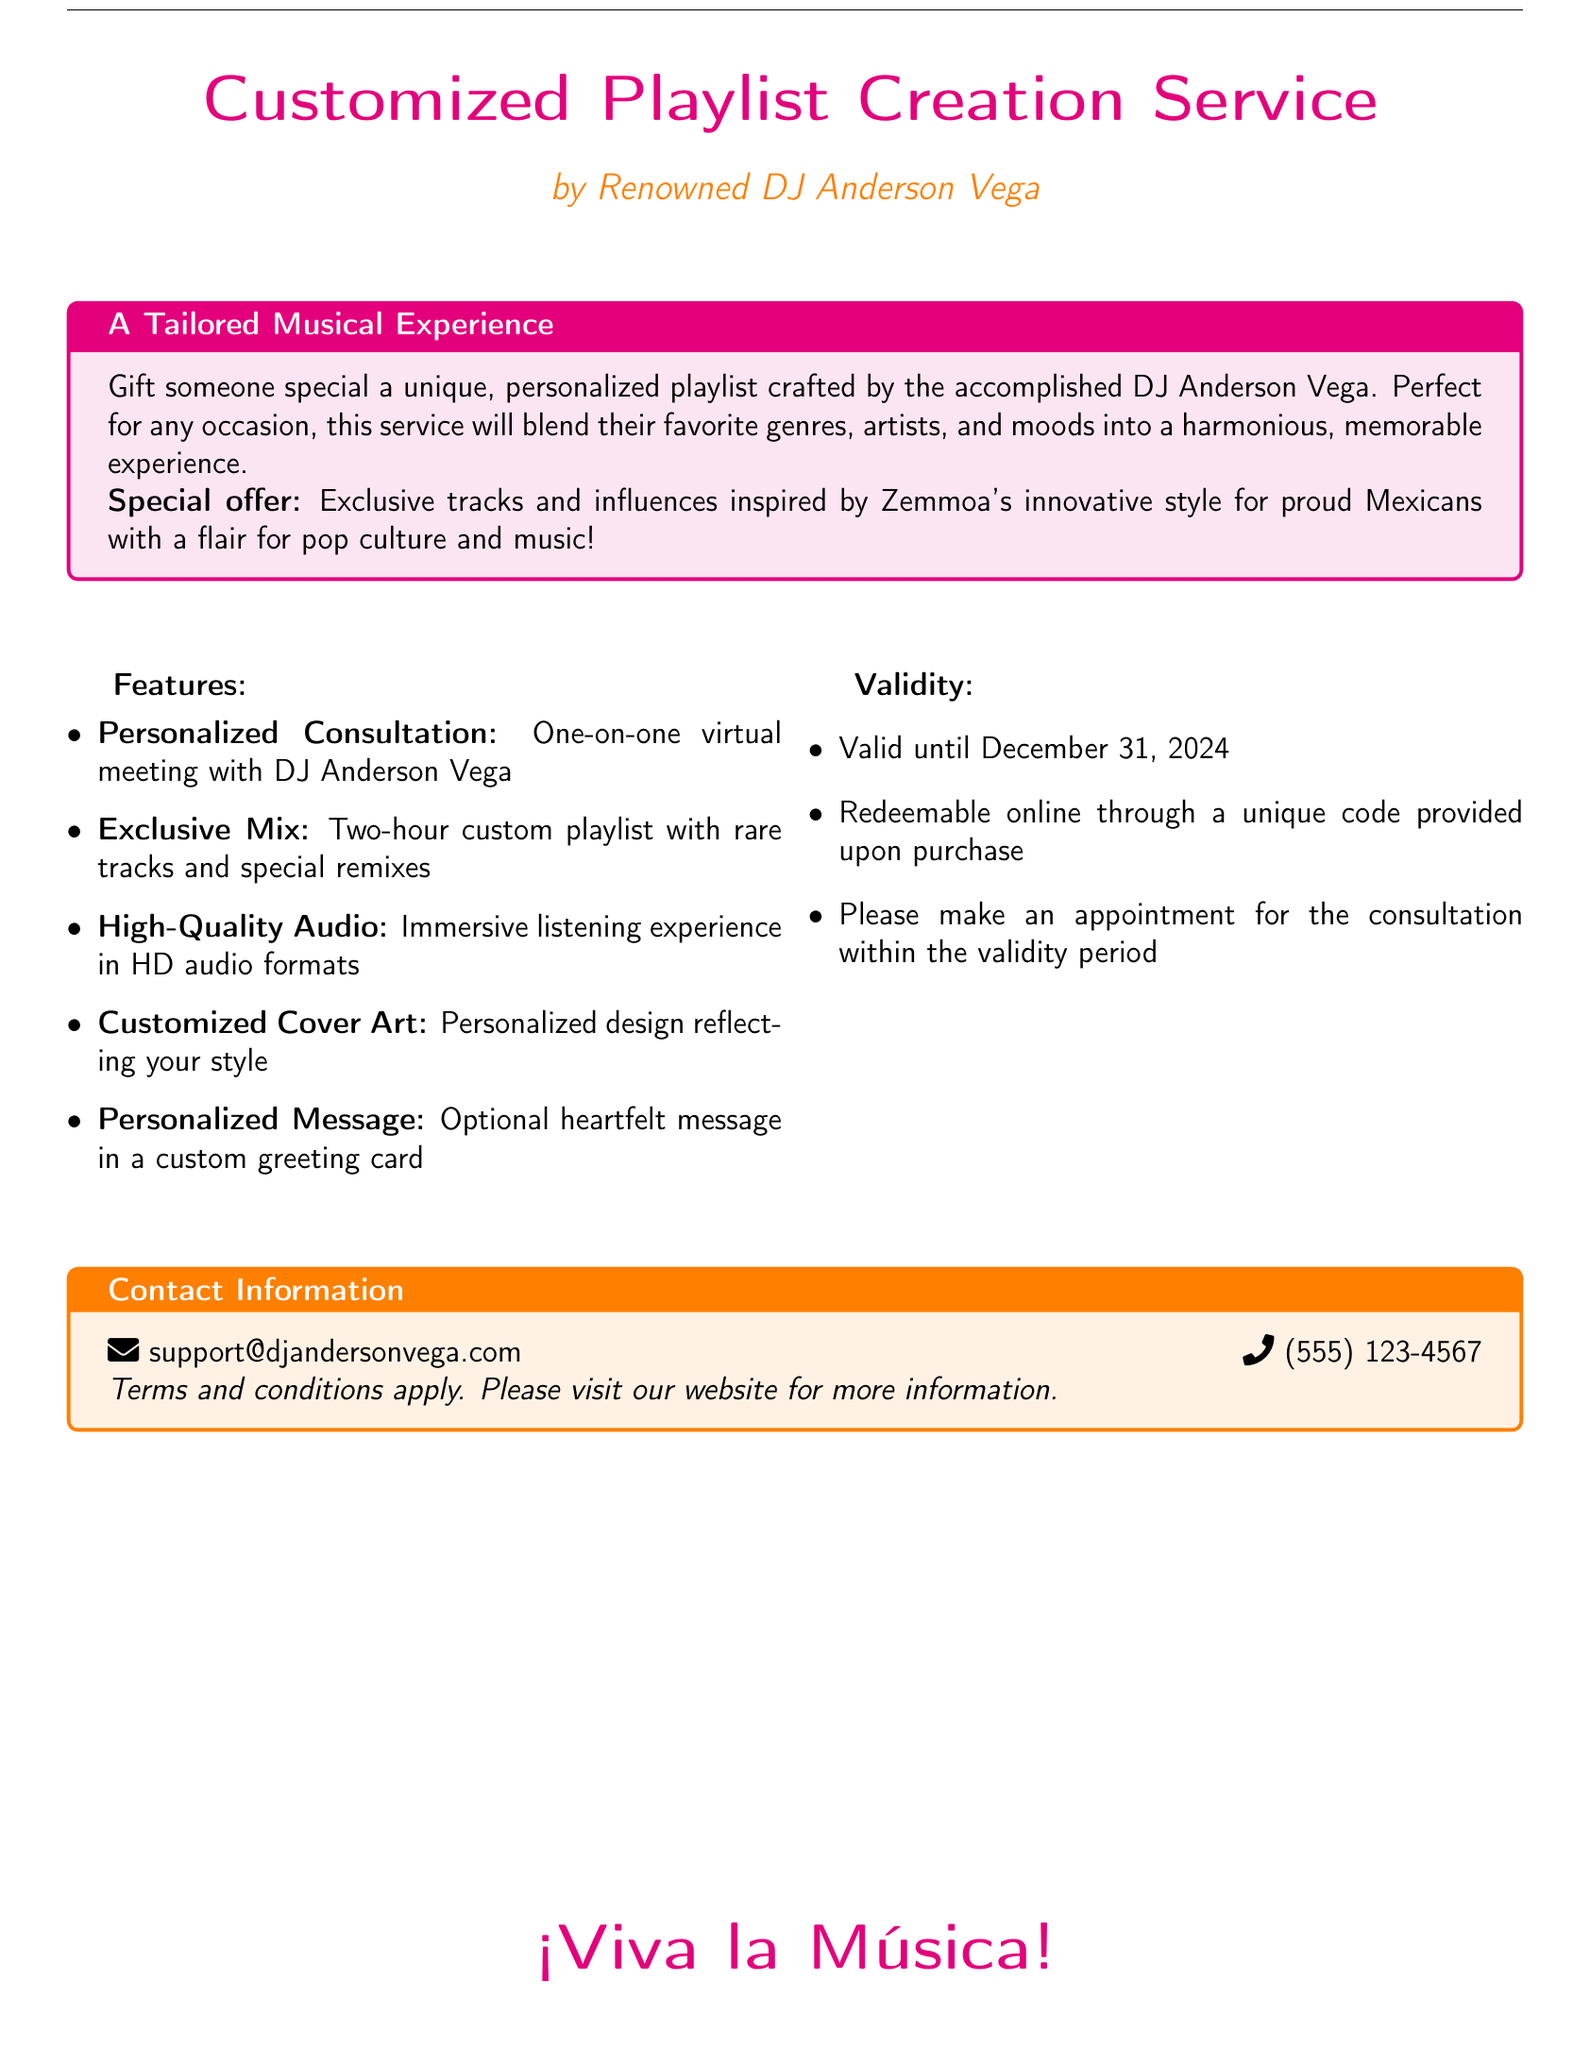What is the name of the DJ? The DJ's name is prominently featured at the top of the document, identifying him as Anderson Vega.
Answer: Anderson Vega What is the validity period of the gift voucher? The validity of the voucher is mentioned in a list, which states it is valid until December 31, 2024.
Answer: December 31, 2024 What is included in the personalized consultation? The document specifies that the consultation involves a one-on-one virtual meeting with the DJ, allowing for personalized interaction.
Answer: One-on-one virtual meeting How long is the custom playlist? The document states that the custom playlist spans two hours, indicating the length of the musical experience.
Answer: Two-hour What is the optional feature of the gift voucher? The document mentions an optional feature that allows for a heartfelt message to be included in a custom greeting card.
Answer: Heartfelt message What type of audio format is provided? The document describes that high-quality audio formats are part of the service, enhancing the listening experience.
Answer: HD audio formats What unique element is inspired by Zemmoa's style? The document indicates that the service features exclusive tracks and influences that are inspired by Zemmoa's innovative style.
Answer: Exclusive tracks How can the voucher be redeemed? The document states that the voucher is redeemable online through a unique code that is provided upon purchase.
Answer: Unique code What is the contact email provided? The contact information section lists an email address for inquiries, indicating how to reach for support or questions.
Answer: support@djandersonvega.com 